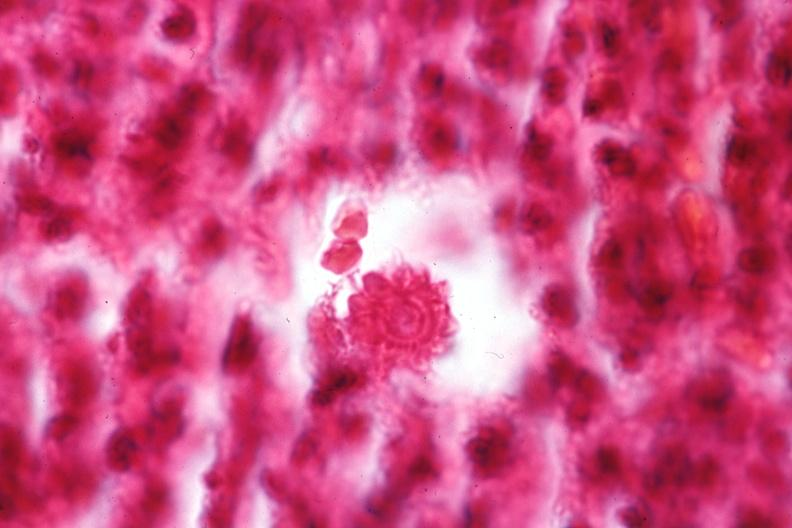what is present?
Answer the question using a single word or phrase. Sporotrichosis 